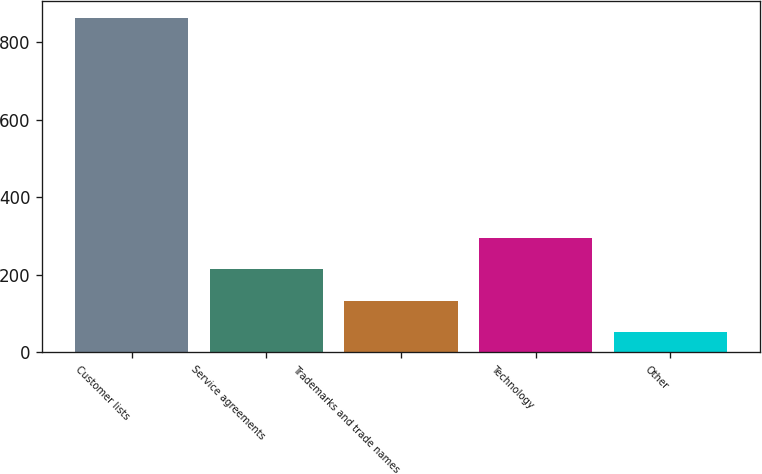Convert chart to OTSL. <chart><loc_0><loc_0><loc_500><loc_500><bar_chart><fcel>Customer lists<fcel>Service agreements<fcel>Trademarks and trade names<fcel>Technology<fcel>Other<nl><fcel>863<fcel>214.2<fcel>133.1<fcel>295.3<fcel>52<nl></chart> 